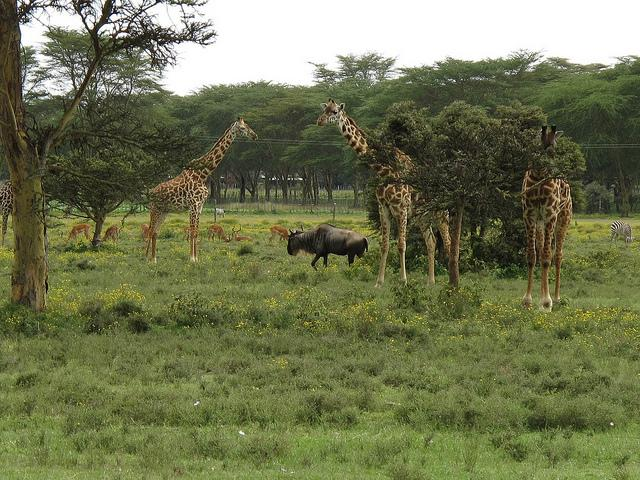How many distinct species of animals are in the field? three 